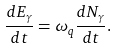<formula> <loc_0><loc_0><loc_500><loc_500>\frac { d E _ { \gamma } } { d t } = \omega _ { q } \frac { d N _ { \gamma } } { d t } .</formula> 